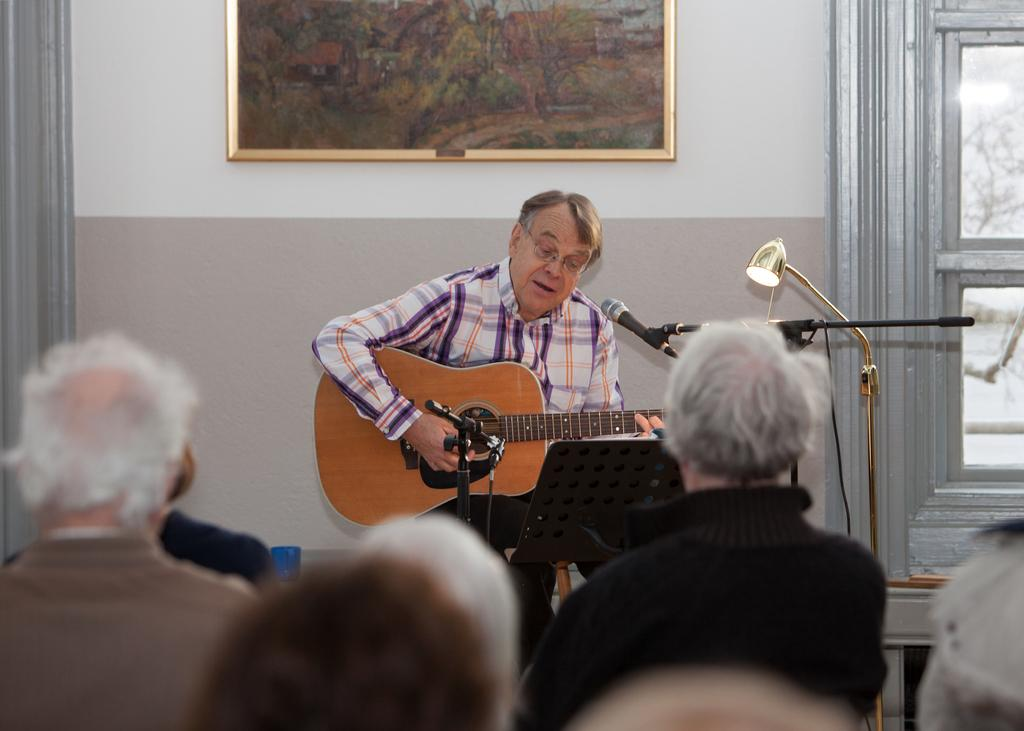What type of structure can be seen in the image? There is a wall in the image. Are there any decorative items on the wall? Yes, there is a photo frame in the image. What architectural feature is present in the image? There is a door in the image. What source of illumination is visible in the image? There is a light in the image. What object is associated with sound amplification in the image? There is a microphone (mike) in the image. Who is present in the image? There is a man sitting in the image, and there are also people present. What is the man holding in the image? The man is holding a guitar. Can you tell me how many quarters are visible in the image? There are no quarters present in the image. What type of animal is interacting with the people in the image? There is no animal present in the image; it features a man holding a guitar and other people. 